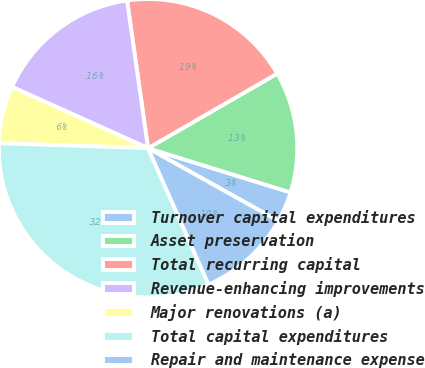Convert chart to OTSL. <chart><loc_0><loc_0><loc_500><loc_500><pie_chart><fcel>Turnover capital expenditures<fcel>Asset preservation<fcel>Total recurring capital<fcel>Revenue-enhancing improvements<fcel>Major renovations (a)<fcel>Total capital expenditures<fcel>Repair and maintenance expense<nl><fcel>3.31%<fcel>13.13%<fcel>18.91%<fcel>16.02%<fcel>6.2%<fcel>32.18%<fcel>10.25%<nl></chart> 